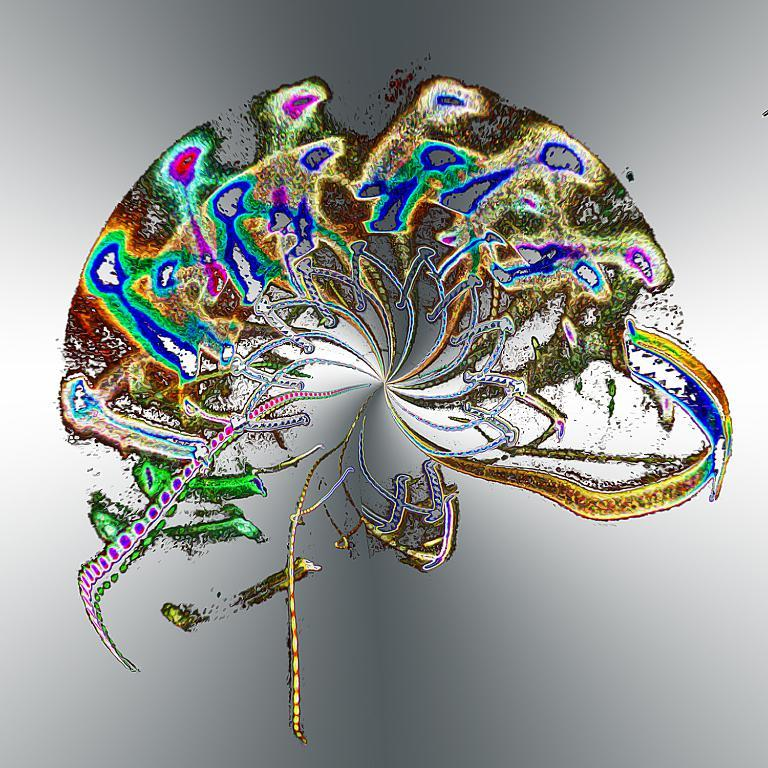What type of art is featured in the image? The image contains digital art. What colors are used in the digital art? The digital art has pink, green, blue, gold, and white colors. How would you describe the background of the image? The background of the image is ash and white colored. Can you see a wrench being used in the digital art? There is no wrench present in the digital art; it is a piece of digital art featuring various colors and shapes. Are there any people depicted in the digital art, and if so, are they jumping? The digital art does not depict any people, so there is no jumping or any other human actions taking place. 